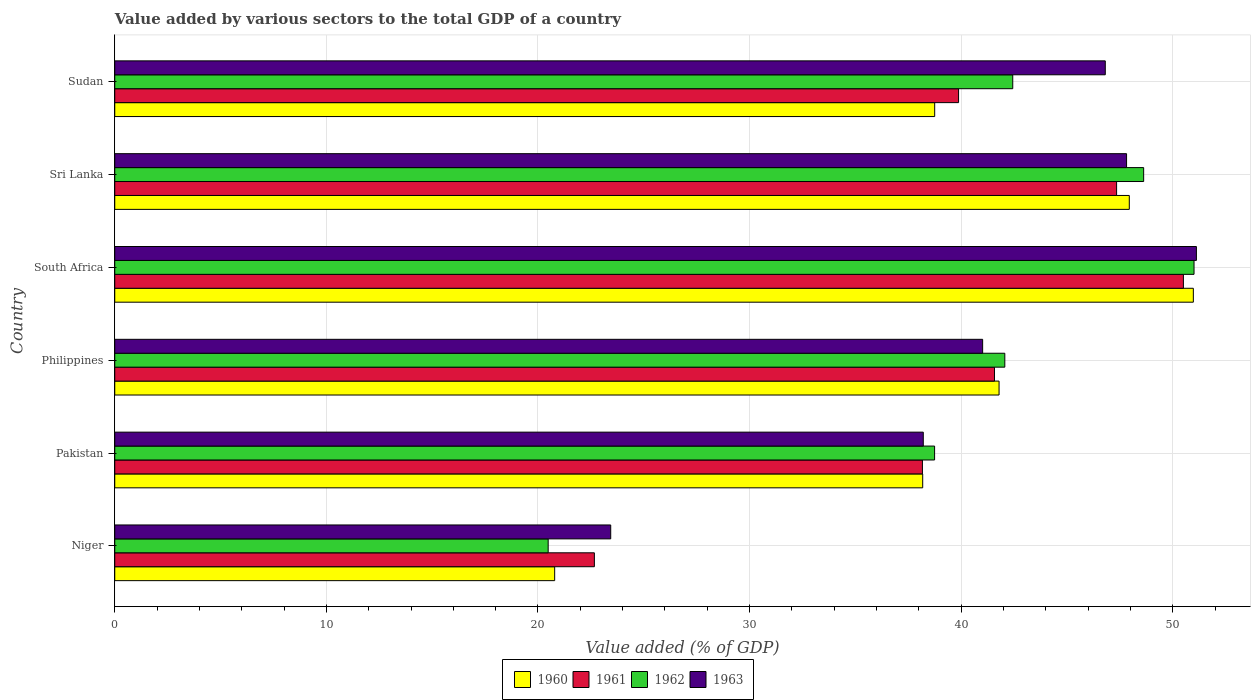How many groups of bars are there?
Make the answer very short. 6. Are the number of bars per tick equal to the number of legend labels?
Offer a very short reply. Yes. How many bars are there on the 3rd tick from the top?
Your response must be concise. 4. How many bars are there on the 1st tick from the bottom?
Provide a short and direct response. 4. What is the label of the 1st group of bars from the top?
Offer a very short reply. Sudan. What is the value added by various sectors to the total GDP in 1962 in Sri Lanka?
Provide a succinct answer. 48.62. Across all countries, what is the maximum value added by various sectors to the total GDP in 1960?
Give a very brief answer. 50.97. Across all countries, what is the minimum value added by various sectors to the total GDP in 1962?
Give a very brief answer. 20.48. In which country was the value added by various sectors to the total GDP in 1960 maximum?
Keep it short and to the point. South Africa. In which country was the value added by various sectors to the total GDP in 1963 minimum?
Ensure brevity in your answer.  Niger. What is the total value added by various sectors to the total GDP in 1962 in the graph?
Offer a terse response. 243.36. What is the difference between the value added by various sectors to the total GDP in 1960 in Philippines and that in Sri Lanka?
Offer a terse response. -6.15. What is the difference between the value added by various sectors to the total GDP in 1962 in South Africa and the value added by various sectors to the total GDP in 1963 in Pakistan?
Offer a very short reply. 12.8. What is the average value added by various sectors to the total GDP in 1960 per country?
Ensure brevity in your answer.  39.74. What is the difference between the value added by various sectors to the total GDP in 1960 and value added by various sectors to the total GDP in 1962 in Niger?
Offer a terse response. 0.31. What is the ratio of the value added by various sectors to the total GDP in 1962 in Niger to that in Philippines?
Make the answer very short. 0.49. Is the value added by various sectors to the total GDP in 1963 in Niger less than that in Philippines?
Give a very brief answer. Yes. Is the difference between the value added by various sectors to the total GDP in 1960 in South Africa and Sri Lanka greater than the difference between the value added by various sectors to the total GDP in 1962 in South Africa and Sri Lanka?
Offer a very short reply. Yes. What is the difference between the highest and the second highest value added by various sectors to the total GDP in 1961?
Your answer should be compact. 3.16. What is the difference between the highest and the lowest value added by various sectors to the total GDP in 1962?
Offer a terse response. 30.52. In how many countries, is the value added by various sectors to the total GDP in 1961 greater than the average value added by various sectors to the total GDP in 1961 taken over all countries?
Offer a very short reply. 3. How many bars are there?
Your response must be concise. 24. Are all the bars in the graph horizontal?
Your answer should be very brief. Yes. What is the difference between two consecutive major ticks on the X-axis?
Your answer should be very brief. 10. Are the values on the major ticks of X-axis written in scientific E-notation?
Offer a very short reply. No. How many legend labels are there?
Provide a succinct answer. 4. How are the legend labels stacked?
Provide a succinct answer. Horizontal. What is the title of the graph?
Your answer should be very brief. Value added by various sectors to the total GDP of a country. Does "1998" appear as one of the legend labels in the graph?
Keep it short and to the point. No. What is the label or title of the X-axis?
Keep it short and to the point. Value added (% of GDP). What is the label or title of the Y-axis?
Make the answer very short. Country. What is the Value added (% of GDP) in 1960 in Niger?
Ensure brevity in your answer.  20.79. What is the Value added (% of GDP) of 1961 in Niger?
Offer a terse response. 22.67. What is the Value added (% of GDP) of 1962 in Niger?
Provide a succinct answer. 20.48. What is the Value added (% of GDP) in 1963 in Niger?
Your answer should be compact. 23.44. What is the Value added (% of GDP) in 1960 in Pakistan?
Offer a very short reply. 38.18. What is the Value added (% of GDP) in 1961 in Pakistan?
Your answer should be compact. 38.17. What is the Value added (% of GDP) of 1962 in Pakistan?
Make the answer very short. 38.74. What is the Value added (% of GDP) of 1963 in Pakistan?
Your response must be concise. 38.21. What is the Value added (% of GDP) of 1960 in Philippines?
Keep it short and to the point. 41.79. What is the Value added (% of GDP) of 1961 in Philippines?
Ensure brevity in your answer.  41.57. What is the Value added (% of GDP) in 1962 in Philippines?
Provide a succinct answer. 42.06. What is the Value added (% of GDP) of 1963 in Philippines?
Give a very brief answer. 41.01. What is the Value added (% of GDP) in 1960 in South Africa?
Your answer should be very brief. 50.97. What is the Value added (% of GDP) of 1961 in South Africa?
Your response must be concise. 50.5. What is the Value added (% of GDP) in 1962 in South Africa?
Your answer should be very brief. 51.01. What is the Value added (% of GDP) of 1963 in South Africa?
Your answer should be compact. 51.12. What is the Value added (% of GDP) of 1960 in Sri Lanka?
Provide a short and direct response. 47.95. What is the Value added (% of GDP) in 1961 in Sri Lanka?
Make the answer very short. 47.35. What is the Value added (% of GDP) in 1962 in Sri Lanka?
Your response must be concise. 48.62. What is the Value added (% of GDP) of 1963 in Sri Lanka?
Your answer should be very brief. 47.82. What is the Value added (% of GDP) in 1960 in Sudan?
Provide a succinct answer. 38.75. What is the Value added (% of GDP) of 1961 in Sudan?
Provide a short and direct response. 39.88. What is the Value added (% of GDP) in 1962 in Sudan?
Your answer should be compact. 42.44. What is the Value added (% of GDP) in 1963 in Sudan?
Your answer should be very brief. 46.81. Across all countries, what is the maximum Value added (% of GDP) in 1960?
Keep it short and to the point. 50.97. Across all countries, what is the maximum Value added (% of GDP) of 1961?
Your answer should be compact. 50.5. Across all countries, what is the maximum Value added (% of GDP) of 1962?
Offer a very short reply. 51.01. Across all countries, what is the maximum Value added (% of GDP) in 1963?
Offer a terse response. 51.12. Across all countries, what is the minimum Value added (% of GDP) in 1960?
Keep it short and to the point. 20.79. Across all countries, what is the minimum Value added (% of GDP) in 1961?
Provide a short and direct response. 22.67. Across all countries, what is the minimum Value added (% of GDP) in 1962?
Your answer should be compact. 20.48. Across all countries, what is the minimum Value added (% of GDP) of 1963?
Offer a terse response. 23.44. What is the total Value added (% of GDP) of 1960 in the graph?
Give a very brief answer. 238.43. What is the total Value added (% of GDP) of 1961 in the graph?
Ensure brevity in your answer.  240.14. What is the total Value added (% of GDP) in 1962 in the graph?
Your response must be concise. 243.36. What is the total Value added (% of GDP) of 1963 in the graph?
Your response must be concise. 248.41. What is the difference between the Value added (% of GDP) of 1960 in Niger and that in Pakistan?
Provide a succinct answer. -17.39. What is the difference between the Value added (% of GDP) in 1961 in Niger and that in Pakistan?
Your answer should be compact. -15.5. What is the difference between the Value added (% of GDP) of 1962 in Niger and that in Pakistan?
Offer a terse response. -18.26. What is the difference between the Value added (% of GDP) of 1963 in Niger and that in Pakistan?
Give a very brief answer. -14.77. What is the difference between the Value added (% of GDP) in 1960 in Niger and that in Philippines?
Ensure brevity in your answer.  -21. What is the difference between the Value added (% of GDP) of 1961 in Niger and that in Philippines?
Give a very brief answer. -18.91. What is the difference between the Value added (% of GDP) in 1962 in Niger and that in Philippines?
Your answer should be compact. -21.58. What is the difference between the Value added (% of GDP) in 1963 in Niger and that in Philippines?
Give a very brief answer. -17.58. What is the difference between the Value added (% of GDP) of 1960 in Niger and that in South Africa?
Keep it short and to the point. -30.18. What is the difference between the Value added (% of GDP) of 1961 in Niger and that in South Africa?
Provide a succinct answer. -27.84. What is the difference between the Value added (% of GDP) in 1962 in Niger and that in South Africa?
Provide a short and direct response. -30.52. What is the difference between the Value added (% of GDP) of 1963 in Niger and that in South Africa?
Ensure brevity in your answer.  -27.68. What is the difference between the Value added (% of GDP) in 1960 in Niger and that in Sri Lanka?
Keep it short and to the point. -27.16. What is the difference between the Value added (% of GDP) in 1961 in Niger and that in Sri Lanka?
Your answer should be very brief. -24.68. What is the difference between the Value added (% of GDP) in 1962 in Niger and that in Sri Lanka?
Provide a short and direct response. -28.14. What is the difference between the Value added (% of GDP) in 1963 in Niger and that in Sri Lanka?
Your response must be concise. -24.38. What is the difference between the Value added (% of GDP) of 1960 in Niger and that in Sudan?
Your answer should be very brief. -17.96. What is the difference between the Value added (% of GDP) of 1961 in Niger and that in Sudan?
Ensure brevity in your answer.  -17.21. What is the difference between the Value added (% of GDP) of 1962 in Niger and that in Sudan?
Your answer should be compact. -21.96. What is the difference between the Value added (% of GDP) in 1963 in Niger and that in Sudan?
Your answer should be compact. -23.37. What is the difference between the Value added (% of GDP) of 1960 in Pakistan and that in Philippines?
Make the answer very short. -3.61. What is the difference between the Value added (% of GDP) of 1961 in Pakistan and that in Philippines?
Your answer should be compact. -3.41. What is the difference between the Value added (% of GDP) in 1962 in Pakistan and that in Philippines?
Your answer should be compact. -3.32. What is the difference between the Value added (% of GDP) of 1963 in Pakistan and that in Philippines?
Your answer should be compact. -2.81. What is the difference between the Value added (% of GDP) of 1960 in Pakistan and that in South Africa?
Your answer should be compact. -12.79. What is the difference between the Value added (% of GDP) in 1961 in Pakistan and that in South Africa?
Your response must be concise. -12.33. What is the difference between the Value added (% of GDP) of 1962 in Pakistan and that in South Africa?
Make the answer very short. -12.26. What is the difference between the Value added (% of GDP) of 1963 in Pakistan and that in South Africa?
Offer a very short reply. -12.91. What is the difference between the Value added (% of GDP) in 1960 in Pakistan and that in Sri Lanka?
Make the answer very short. -9.76. What is the difference between the Value added (% of GDP) in 1961 in Pakistan and that in Sri Lanka?
Give a very brief answer. -9.18. What is the difference between the Value added (% of GDP) of 1962 in Pakistan and that in Sri Lanka?
Your answer should be compact. -9.88. What is the difference between the Value added (% of GDP) of 1963 in Pakistan and that in Sri Lanka?
Your answer should be compact. -9.61. What is the difference between the Value added (% of GDP) of 1960 in Pakistan and that in Sudan?
Your answer should be very brief. -0.57. What is the difference between the Value added (% of GDP) of 1961 in Pakistan and that in Sudan?
Ensure brevity in your answer.  -1.71. What is the difference between the Value added (% of GDP) of 1962 in Pakistan and that in Sudan?
Keep it short and to the point. -3.69. What is the difference between the Value added (% of GDP) of 1963 in Pakistan and that in Sudan?
Ensure brevity in your answer.  -8.6. What is the difference between the Value added (% of GDP) in 1960 in Philippines and that in South Africa?
Your response must be concise. -9.18. What is the difference between the Value added (% of GDP) in 1961 in Philippines and that in South Africa?
Give a very brief answer. -8.93. What is the difference between the Value added (% of GDP) in 1962 in Philippines and that in South Africa?
Make the answer very short. -8.94. What is the difference between the Value added (% of GDP) of 1963 in Philippines and that in South Africa?
Offer a terse response. -10.1. What is the difference between the Value added (% of GDP) in 1960 in Philippines and that in Sri Lanka?
Keep it short and to the point. -6.15. What is the difference between the Value added (% of GDP) of 1961 in Philippines and that in Sri Lanka?
Provide a short and direct response. -5.77. What is the difference between the Value added (% of GDP) in 1962 in Philippines and that in Sri Lanka?
Your answer should be compact. -6.56. What is the difference between the Value added (% of GDP) in 1963 in Philippines and that in Sri Lanka?
Provide a short and direct response. -6.8. What is the difference between the Value added (% of GDP) in 1960 in Philippines and that in Sudan?
Give a very brief answer. 3.04. What is the difference between the Value added (% of GDP) of 1961 in Philippines and that in Sudan?
Your answer should be compact. 1.7. What is the difference between the Value added (% of GDP) in 1962 in Philippines and that in Sudan?
Provide a succinct answer. -0.38. What is the difference between the Value added (% of GDP) in 1963 in Philippines and that in Sudan?
Ensure brevity in your answer.  -5.8. What is the difference between the Value added (% of GDP) of 1960 in South Africa and that in Sri Lanka?
Offer a terse response. 3.03. What is the difference between the Value added (% of GDP) in 1961 in South Africa and that in Sri Lanka?
Make the answer very short. 3.16. What is the difference between the Value added (% of GDP) in 1962 in South Africa and that in Sri Lanka?
Offer a very short reply. 2.38. What is the difference between the Value added (% of GDP) in 1963 in South Africa and that in Sri Lanka?
Offer a very short reply. 3.3. What is the difference between the Value added (% of GDP) of 1960 in South Africa and that in Sudan?
Your answer should be compact. 12.22. What is the difference between the Value added (% of GDP) of 1961 in South Africa and that in Sudan?
Your answer should be very brief. 10.63. What is the difference between the Value added (% of GDP) of 1962 in South Africa and that in Sudan?
Your answer should be compact. 8.57. What is the difference between the Value added (% of GDP) in 1963 in South Africa and that in Sudan?
Your answer should be compact. 4.31. What is the difference between the Value added (% of GDP) in 1960 in Sri Lanka and that in Sudan?
Provide a short and direct response. 9.2. What is the difference between the Value added (% of GDP) of 1961 in Sri Lanka and that in Sudan?
Provide a short and direct response. 7.47. What is the difference between the Value added (% of GDP) of 1962 in Sri Lanka and that in Sudan?
Ensure brevity in your answer.  6.19. What is the difference between the Value added (% of GDP) of 1963 in Sri Lanka and that in Sudan?
Keep it short and to the point. 1.01. What is the difference between the Value added (% of GDP) of 1960 in Niger and the Value added (% of GDP) of 1961 in Pakistan?
Provide a short and direct response. -17.38. What is the difference between the Value added (% of GDP) of 1960 in Niger and the Value added (% of GDP) of 1962 in Pakistan?
Make the answer very short. -17.95. What is the difference between the Value added (% of GDP) in 1960 in Niger and the Value added (% of GDP) in 1963 in Pakistan?
Keep it short and to the point. -17.42. What is the difference between the Value added (% of GDP) in 1961 in Niger and the Value added (% of GDP) in 1962 in Pakistan?
Your response must be concise. -16.08. What is the difference between the Value added (% of GDP) in 1961 in Niger and the Value added (% of GDP) in 1963 in Pakistan?
Offer a terse response. -15.54. What is the difference between the Value added (% of GDP) of 1962 in Niger and the Value added (% of GDP) of 1963 in Pakistan?
Your response must be concise. -17.73. What is the difference between the Value added (% of GDP) of 1960 in Niger and the Value added (% of GDP) of 1961 in Philippines?
Provide a succinct answer. -20.78. What is the difference between the Value added (% of GDP) in 1960 in Niger and the Value added (% of GDP) in 1962 in Philippines?
Your answer should be very brief. -21.27. What is the difference between the Value added (% of GDP) of 1960 in Niger and the Value added (% of GDP) of 1963 in Philippines?
Keep it short and to the point. -20.22. What is the difference between the Value added (% of GDP) in 1961 in Niger and the Value added (% of GDP) in 1962 in Philippines?
Your answer should be very brief. -19.4. What is the difference between the Value added (% of GDP) of 1961 in Niger and the Value added (% of GDP) of 1963 in Philippines?
Your answer should be compact. -18.35. What is the difference between the Value added (% of GDP) in 1962 in Niger and the Value added (% of GDP) in 1963 in Philippines?
Give a very brief answer. -20.53. What is the difference between the Value added (% of GDP) of 1960 in Niger and the Value added (% of GDP) of 1961 in South Africa?
Make the answer very short. -29.71. What is the difference between the Value added (% of GDP) in 1960 in Niger and the Value added (% of GDP) in 1962 in South Africa?
Give a very brief answer. -30.22. What is the difference between the Value added (% of GDP) in 1960 in Niger and the Value added (% of GDP) in 1963 in South Africa?
Your answer should be compact. -30.33. What is the difference between the Value added (% of GDP) in 1961 in Niger and the Value added (% of GDP) in 1962 in South Africa?
Provide a short and direct response. -28.34. What is the difference between the Value added (% of GDP) in 1961 in Niger and the Value added (% of GDP) in 1963 in South Africa?
Ensure brevity in your answer.  -28.45. What is the difference between the Value added (% of GDP) of 1962 in Niger and the Value added (% of GDP) of 1963 in South Africa?
Your answer should be compact. -30.63. What is the difference between the Value added (% of GDP) of 1960 in Niger and the Value added (% of GDP) of 1961 in Sri Lanka?
Keep it short and to the point. -26.56. What is the difference between the Value added (% of GDP) in 1960 in Niger and the Value added (% of GDP) in 1962 in Sri Lanka?
Your answer should be very brief. -27.83. What is the difference between the Value added (% of GDP) in 1960 in Niger and the Value added (% of GDP) in 1963 in Sri Lanka?
Give a very brief answer. -27.03. What is the difference between the Value added (% of GDP) of 1961 in Niger and the Value added (% of GDP) of 1962 in Sri Lanka?
Your answer should be compact. -25.96. What is the difference between the Value added (% of GDP) of 1961 in Niger and the Value added (% of GDP) of 1963 in Sri Lanka?
Your answer should be very brief. -25.15. What is the difference between the Value added (% of GDP) of 1962 in Niger and the Value added (% of GDP) of 1963 in Sri Lanka?
Keep it short and to the point. -27.33. What is the difference between the Value added (% of GDP) of 1960 in Niger and the Value added (% of GDP) of 1961 in Sudan?
Your answer should be very brief. -19.09. What is the difference between the Value added (% of GDP) in 1960 in Niger and the Value added (% of GDP) in 1962 in Sudan?
Keep it short and to the point. -21.65. What is the difference between the Value added (% of GDP) of 1960 in Niger and the Value added (% of GDP) of 1963 in Sudan?
Offer a very short reply. -26.02. What is the difference between the Value added (% of GDP) of 1961 in Niger and the Value added (% of GDP) of 1962 in Sudan?
Give a very brief answer. -19.77. What is the difference between the Value added (% of GDP) in 1961 in Niger and the Value added (% of GDP) in 1963 in Sudan?
Your answer should be compact. -24.14. What is the difference between the Value added (% of GDP) in 1962 in Niger and the Value added (% of GDP) in 1963 in Sudan?
Offer a terse response. -26.33. What is the difference between the Value added (% of GDP) in 1960 in Pakistan and the Value added (% of GDP) in 1961 in Philippines?
Offer a terse response. -3.39. What is the difference between the Value added (% of GDP) of 1960 in Pakistan and the Value added (% of GDP) of 1962 in Philippines?
Keep it short and to the point. -3.88. What is the difference between the Value added (% of GDP) in 1960 in Pakistan and the Value added (% of GDP) in 1963 in Philippines?
Keep it short and to the point. -2.83. What is the difference between the Value added (% of GDP) in 1961 in Pakistan and the Value added (% of GDP) in 1962 in Philippines?
Your response must be concise. -3.89. What is the difference between the Value added (% of GDP) in 1961 in Pakistan and the Value added (% of GDP) in 1963 in Philippines?
Your answer should be compact. -2.85. What is the difference between the Value added (% of GDP) of 1962 in Pakistan and the Value added (% of GDP) of 1963 in Philippines?
Give a very brief answer. -2.27. What is the difference between the Value added (% of GDP) of 1960 in Pakistan and the Value added (% of GDP) of 1961 in South Africa?
Provide a short and direct response. -12.32. What is the difference between the Value added (% of GDP) of 1960 in Pakistan and the Value added (% of GDP) of 1962 in South Africa?
Provide a succinct answer. -12.82. What is the difference between the Value added (% of GDP) of 1960 in Pakistan and the Value added (% of GDP) of 1963 in South Africa?
Make the answer very short. -12.93. What is the difference between the Value added (% of GDP) in 1961 in Pakistan and the Value added (% of GDP) in 1962 in South Africa?
Make the answer very short. -12.84. What is the difference between the Value added (% of GDP) in 1961 in Pakistan and the Value added (% of GDP) in 1963 in South Africa?
Your response must be concise. -12.95. What is the difference between the Value added (% of GDP) in 1962 in Pakistan and the Value added (% of GDP) in 1963 in South Africa?
Offer a very short reply. -12.37. What is the difference between the Value added (% of GDP) in 1960 in Pakistan and the Value added (% of GDP) in 1961 in Sri Lanka?
Your response must be concise. -9.16. What is the difference between the Value added (% of GDP) in 1960 in Pakistan and the Value added (% of GDP) in 1962 in Sri Lanka?
Offer a terse response. -10.44. What is the difference between the Value added (% of GDP) in 1960 in Pakistan and the Value added (% of GDP) in 1963 in Sri Lanka?
Your answer should be compact. -9.63. What is the difference between the Value added (% of GDP) of 1961 in Pakistan and the Value added (% of GDP) of 1962 in Sri Lanka?
Give a very brief answer. -10.46. What is the difference between the Value added (% of GDP) of 1961 in Pakistan and the Value added (% of GDP) of 1963 in Sri Lanka?
Offer a terse response. -9.65. What is the difference between the Value added (% of GDP) in 1962 in Pakistan and the Value added (% of GDP) in 1963 in Sri Lanka?
Ensure brevity in your answer.  -9.07. What is the difference between the Value added (% of GDP) in 1960 in Pakistan and the Value added (% of GDP) in 1961 in Sudan?
Your answer should be compact. -1.69. What is the difference between the Value added (% of GDP) in 1960 in Pakistan and the Value added (% of GDP) in 1962 in Sudan?
Ensure brevity in your answer.  -4.26. What is the difference between the Value added (% of GDP) of 1960 in Pakistan and the Value added (% of GDP) of 1963 in Sudan?
Make the answer very short. -8.63. What is the difference between the Value added (% of GDP) of 1961 in Pakistan and the Value added (% of GDP) of 1962 in Sudan?
Provide a short and direct response. -4.27. What is the difference between the Value added (% of GDP) of 1961 in Pakistan and the Value added (% of GDP) of 1963 in Sudan?
Offer a terse response. -8.64. What is the difference between the Value added (% of GDP) in 1962 in Pakistan and the Value added (% of GDP) in 1963 in Sudan?
Give a very brief answer. -8.07. What is the difference between the Value added (% of GDP) of 1960 in Philippines and the Value added (% of GDP) of 1961 in South Africa?
Keep it short and to the point. -8.71. What is the difference between the Value added (% of GDP) in 1960 in Philippines and the Value added (% of GDP) in 1962 in South Africa?
Provide a short and direct response. -9.21. What is the difference between the Value added (% of GDP) in 1960 in Philippines and the Value added (% of GDP) in 1963 in South Africa?
Make the answer very short. -9.33. What is the difference between the Value added (% of GDP) in 1961 in Philippines and the Value added (% of GDP) in 1962 in South Africa?
Offer a very short reply. -9.43. What is the difference between the Value added (% of GDP) in 1961 in Philippines and the Value added (% of GDP) in 1963 in South Africa?
Keep it short and to the point. -9.54. What is the difference between the Value added (% of GDP) of 1962 in Philippines and the Value added (% of GDP) of 1963 in South Africa?
Keep it short and to the point. -9.05. What is the difference between the Value added (% of GDP) of 1960 in Philippines and the Value added (% of GDP) of 1961 in Sri Lanka?
Make the answer very short. -5.55. What is the difference between the Value added (% of GDP) in 1960 in Philippines and the Value added (% of GDP) in 1962 in Sri Lanka?
Ensure brevity in your answer.  -6.83. What is the difference between the Value added (% of GDP) in 1960 in Philippines and the Value added (% of GDP) in 1963 in Sri Lanka?
Offer a very short reply. -6.03. What is the difference between the Value added (% of GDP) of 1961 in Philippines and the Value added (% of GDP) of 1962 in Sri Lanka?
Your answer should be compact. -7.05. What is the difference between the Value added (% of GDP) in 1961 in Philippines and the Value added (% of GDP) in 1963 in Sri Lanka?
Offer a very short reply. -6.24. What is the difference between the Value added (% of GDP) of 1962 in Philippines and the Value added (% of GDP) of 1963 in Sri Lanka?
Offer a very short reply. -5.75. What is the difference between the Value added (% of GDP) of 1960 in Philippines and the Value added (% of GDP) of 1961 in Sudan?
Ensure brevity in your answer.  1.91. What is the difference between the Value added (% of GDP) of 1960 in Philippines and the Value added (% of GDP) of 1962 in Sudan?
Make the answer very short. -0.65. What is the difference between the Value added (% of GDP) in 1960 in Philippines and the Value added (% of GDP) in 1963 in Sudan?
Keep it short and to the point. -5.02. What is the difference between the Value added (% of GDP) of 1961 in Philippines and the Value added (% of GDP) of 1962 in Sudan?
Provide a succinct answer. -0.86. What is the difference between the Value added (% of GDP) in 1961 in Philippines and the Value added (% of GDP) in 1963 in Sudan?
Make the answer very short. -5.24. What is the difference between the Value added (% of GDP) of 1962 in Philippines and the Value added (% of GDP) of 1963 in Sudan?
Ensure brevity in your answer.  -4.75. What is the difference between the Value added (% of GDP) in 1960 in South Africa and the Value added (% of GDP) in 1961 in Sri Lanka?
Offer a very short reply. 3.63. What is the difference between the Value added (% of GDP) of 1960 in South Africa and the Value added (% of GDP) of 1962 in Sri Lanka?
Offer a terse response. 2.35. What is the difference between the Value added (% of GDP) of 1960 in South Africa and the Value added (% of GDP) of 1963 in Sri Lanka?
Your answer should be compact. 3.16. What is the difference between the Value added (% of GDP) in 1961 in South Africa and the Value added (% of GDP) in 1962 in Sri Lanka?
Offer a terse response. 1.88. What is the difference between the Value added (% of GDP) of 1961 in South Africa and the Value added (% of GDP) of 1963 in Sri Lanka?
Offer a terse response. 2.69. What is the difference between the Value added (% of GDP) in 1962 in South Africa and the Value added (% of GDP) in 1963 in Sri Lanka?
Give a very brief answer. 3.19. What is the difference between the Value added (% of GDP) in 1960 in South Africa and the Value added (% of GDP) in 1961 in Sudan?
Make the answer very short. 11.09. What is the difference between the Value added (% of GDP) in 1960 in South Africa and the Value added (% of GDP) in 1962 in Sudan?
Your answer should be compact. 8.53. What is the difference between the Value added (% of GDP) in 1960 in South Africa and the Value added (% of GDP) in 1963 in Sudan?
Give a very brief answer. 4.16. What is the difference between the Value added (% of GDP) in 1961 in South Africa and the Value added (% of GDP) in 1962 in Sudan?
Keep it short and to the point. 8.07. What is the difference between the Value added (% of GDP) of 1961 in South Africa and the Value added (% of GDP) of 1963 in Sudan?
Your answer should be very brief. 3.69. What is the difference between the Value added (% of GDP) of 1962 in South Africa and the Value added (% of GDP) of 1963 in Sudan?
Keep it short and to the point. 4.19. What is the difference between the Value added (% of GDP) in 1960 in Sri Lanka and the Value added (% of GDP) in 1961 in Sudan?
Make the answer very short. 8.07. What is the difference between the Value added (% of GDP) of 1960 in Sri Lanka and the Value added (% of GDP) of 1962 in Sudan?
Make the answer very short. 5.51. What is the difference between the Value added (% of GDP) of 1960 in Sri Lanka and the Value added (% of GDP) of 1963 in Sudan?
Your answer should be compact. 1.14. What is the difference between the Value added (% of GDP) of 1961 in Sri Lanka and the Value added (% of GDP) of 1962 in Sudan?
Make the answer very short. 4.91. What is the difference between the Value added (% of GDP) of 1961 in Sri Lanka and the Value added (% of GDP) of 1963 in Sudan?
Provide a succinct answer. 0.53. What is the difference between the Value added (% of GDP) in 1962 in Sri Lanka and the Value added (% of GDP) in 1963 in Sudan?
Provide a succinct answer. 1.81. What is the average Value added (% of GDP) of 1960 per country?
Give a very brief answer. 39.74. What is the average Value added (% of GDP) in 1961 per country?
Make the answer very short. 40.02. What is the average Value added (% of GDP) of 1962 per country?
Offer a very short reply. 40.56. What is the average Value added (% of GDP) of 1963 per country?
Keep it short and to the point. 41.4. What is the difference between the Value added (% of GDP) in 1960 and Value added (% of GDP) in 1961 in Niger?
Your answer should be very brief. -1.88. What is the difference between the Value added (% of GDP) in 1960 and Value added (% of GDP) in 1962 in Niger?
Provide a short and direct response. 0.31. What is the difference between the Value added (% of GDP) in 1960 and Value added (% of GDP) in 1963 in Niger?
Offer a very short reply. -2.65. What is the difference between the Value added (% of GDP) in 1961 and Value added (% of GDP) in 1962 in Niger?
Make the answer very short. 2.18. What is the difference between the Value added (% of GDP) of 1961 and Value added (% of GDP) of 1963 in Niger?
Offer a very short reply. -0.77. What is the difference between the Value added (% of GDP) in 1962 and Value added (% of GDP) in 1963 in Niger?
Give a very brief answer. -2.96. What is the difference between the Value added (% of GDP) in 1960 and Value added (% of GDP) in 1961 in Pakistan?
Keep it short and to the point. 0.01. What is the difference between the Value added (% of GDP) of 1960 and Value added (% of GDP) of 1962 in Pakistan?
Make the answer very short. -0.56. What is the difference between the Value added (% of GDP) in 1960 and Value added (% of GDP) in 1963 in Pakistan?
Your answer should be very brief. -0.03. What is the difference between the Value added (% of GDP) of 1961 and Value added (% of GDP) of 1962 in Pakistan?
Your answer should be compact. -0.58. What is the difference between the Value added (% of GDP) of 1961 and Value added (% of GDP) of 1963 in Pakistan?
Make the answer very short. -0.04. What is the difference between the Value added (% of GDP) in 1962 and Value added (% of GDP) in 1963 in Pakistan?
Your answer should be compact. 0.53. What is the difference between the Value added (% of GDP) in 1960 and Value added (% of GDP) in 1961 in Philippines?
Your answer should be compact. 0.22. What is the difference between the Value added (% of GDP) of 1960 and Value added (% of GDP) of 1962 in Philippines?
Your answer should be compact. -0.27. What is the difference between the Value added (% of GDP) in 1960 and Value added (% of GDP) in 1963 in Philippines?
Provide a succinct answer. 0.78. What is the difference between the Value added (% of GDP) of 1961 and Value added (% of GDP) of 1962 in Philippines?
Offer a very short reply. -0.49. What is the difference between the Value added (% of GDP) in 1961 and Value added (% of GDP) in 1963 in Philippines?
Give a very brief answer. 0.56. What is the difference between the Value added (% of GDP) of 1962 and Value added (% of GDP) of 1963 in Philippines?
Keep it short and to the point. 1.05. What is the difference between the Value added (% of GDP) of 1960 and Value added (% of GDP) of 1961 in South Africa?
Provide a short and direct response. 0.47. What is the difference between the Value added (% of GDP) of 1960 and Value added (% of GDP) of 1962 in South Africa?
Provide a succinct answer. -0.03. What is the difference between the Value added (% of GDP) in 1960 and Value added (% of GDP) in 1963 in South Africa?
Your answer should be very brief. -0.15. What is the difference between the Value added (% of GDP) of 1961 and Value added (% of GDP) of 1962 in South Africa?
Offer a terse response. -0.5. What is the difference between the Value added (% of GDP) of 1961 and Value added (% of GDP) of 1963 in South Africa?
Your answer should be compact. -0.61. What is the difference between the Value added (% of GDP) of 1962 and Value added (% of GDP) of 1963 in South Africa?
Provide a succinct answer. -0.11. What is the difference between the Value added (% of GDP) in 1960 and Value added (% of GDP) in 1961 in Sri Lanka?
Ensure brevity in your answer.  0.6. What is the difference between the Value added (% of GDP) of 1960 and Value added (% of GDP) of 1962 in Sri Lanka?
Give a very brief answer. -0.68. What is the difference between the Value added (% of GDP) in 1960 and Value added (% of GDP) in 1963 in Sri Lanka?
Give a very brief answer. 0.13. What is the difference between the Value added (% of GDP) in 1961 and Value added (% of GDP) in 1962 in Sri Lanka?
Your response must be concise. -1.28. What is the difference between the Value added (% of GDP) of 1961 and Value added (% of GDP) of 1963 in Sri Lanka?
Your response must be concise. -0.47. What is the difference between the Value added (% of GDP) of 1962 and Value added (% of GDP) of 1963 in Sri Lanka?
Keep it short and to the point. 0.81. What is the difference between the Value added (% of GDP) in 1960 and Value added (% of GDP) in 1961 in Sudan?
Offer a very short reply. -1.13. What is the difference between the Value added (% of GDP) of 1960 and Value added (% of GDP) of 1962 in Sudan?
Your answer should be compact. -3.69. What is the difference between the Value added (% of GDP) in 1960 and Value added (% of GDP) in 1963 in Sudan?
Your response must be concise. -8.06. What is the difference between the Value added (% of GDP) of 1961 and Value added (% of GDP) of 1962 in Sudan?
Ensure brevity in your answer.  -2.56. What is the difference between the Value added (% of GDP) of 1961 and Value added (% of GDP) of 1963 in Sudan?
Make the answer very short. -6.93. What is the difference between the Value added (% of GDP) of 1962 and Value added (% of GDP) of 1963 in Sudan?
Give a very brief answer. -4.37. What is the ratio of the Value added (% of GDP) in 1960 in Niger to that in Pakistan?
Provide a short and direct response. 0.54. What is the ratio of the Value added (% of GDP) in 1961 in Niger to that in Pakistan?
Make the answer very short. 0.59. What is the ratio of the Value added (% of GDP) of 1962 in Niger to that in Pakistan?
Provide a short and direct response. 0.53. What is the ratio of the Value added (% of GDP) in 1963 in Niger to that in Pakistan?
Make the answer very short. 0.61. What is the ratio of the Value added (% of GDP) of 1960 in Niger to that in Philippines?
Provide a succinct answer. 0.5. What is the ratio of the Value added (% of GDP) of 1961 in Niger to that in Philippines?
Make the answer very short. 0.55. What is the ratio of the Value added (% of GDP) in 1962 in Niger to that in Philippines?
Keep it short and to the point. 0.49. What is the ratio of the Value added (% of GDP) of 1963 in Niger to that in Philippines?
Your answer should be very brief. 0.57. What is the ratio of the Value added (% of GDP) of 1960 in Niger to that in South Africa?
Your answer should be very brief. 0.41. What is the ratio of the Value added (% of GDP) in 1961 in Niger to that in South Africa?
Your response must be concise. 0.45. What is the ratio of the Value added (% of GDP) in 1962 in Niger to that in South Africa?
Offer a terse response. 0.4. What is the ratio of the Value added (% of GDP) in 1963 in Niger to that in South Africa?
Your answer should be compact. 0.46. What is the ratio of the Value added (% of GDP) of 1960 in Niger to that in Sri Lanka?
Your response must be concise. 0.43. What is the ratio of the Value added (% of GDP) of 1961 in Niger to that in Sri Lanka?
Provide a succinct answer. 0.48. What is the ratio of the Value added (% of GDP) of 1962 in Niger to that in Sri Lanka?
Ensure brevity in your answer.  0.42. What is the ratio of the Value added (% of GDP) of 1963 in Niger to that in Sri Lanka?
Your response must be concise. 0.49. What is the ratio of the Value added (% of GDP) in 1960 in Niger to that in Sudan?
Your answer should be compact. 0.54. What is the ratio of the Value added (% of GDP) in 1961 in Niger to that in Sudan?
Ensure brevity in your answer.  0.57. What is the ratio of the Value added (% of GDP) in 1962 in Niger to that in Sudan?
Give a very brief answer. 0.48. What is the ratio of the Value added (% of GDP) in 1963 in Niger to that in Sudan?
Your response must be concise. 0.5. What is the ratio of the Value added (% of GDP) of 1960 in Pakistan to that in Philippines?
Offer a terse response. 0.91. What is the ratio of the Value added (% of GDP) of 1961 in Pakistan to that in Philippines?
Provide a succinct answer. 0.92. What is the ratio of the Value added (% of GDP) of 1962 in Pakistan to that in Philippines?
Give a very brief answer. 0.92. What is the ratio of the Value added (% of GDP) in 1963 in Pakistan to that in Philippines?
Ensure brevity in your answer.  0.93. What is the ratio of the Value added (% of GDP) of 1960 in Pakistan to that in South Africa?
Offer a terse response. 0.75. What is the ratio of the Value added (% of GDP) in 1961 in Pakistan to that in South Africa?
Your response must be concise. 0.76. What is the ratio of the Value added (% of GDP) of 1962 in Pakistan to that in South Africa?
Provide a short and direct response. 0.76. What is the ratio of the Value added (% of GDP) of 1963 in Pakistan to that in South Africa?
Offer a terse response. 0.75. What is the ratio of the Value added (% of GDP) in 1960 in Pakistan to that in Sri Lanka?
Ensure brevity in your answer.  0.8. What is the ratio of the Value added (% of GDP) in 1961 in Pakistan to that in Sri Lanka?
Your answer should be compact. 0.81. What is the ratio of the Value added (% of GDP) in 1962 in Pakistan to that in Sri Lanka?
Ensure brevity in your answer.  0.8. What is the ratio of the Value added (% of GDP) in 1963 in Pakistan to that in Sri Lanka?
Provide a short and direct response. 0.8. What is the ratio of the Value added (% of GDP) of 1960 in Pakistan to that in Sudan?
Make the answer very short. 0.99. What is the ratio of the Value added (% of GDP) in 1961 in Pakistan to that in Sudan?
Keep it short and to the point. 0.96. What is the ratio of the Value added (% of GDP) in 1962 in Pakistan to that in Sudan?
Make the answer very short. 0.91. What is the ratio of the Value added (% of GDP) in 1963 in Pakistan to that in Sudan?
Your answer should be very brief. 0.82. What is the ratio of the Value added (% of GDP) of 1960 in Philippines to that in South Africa?
Ensure brevity in your answer.  0.82. What is the ratio of the Value added (% of GDP) in 1961 in Philippines to that in South Africa?
Keep it short and to the point. 0.82. What is the ratio of the Value added (% of GDP) in 1962 in Philippines to that in South Africa?
Provide a short and direct response. 0.82. What is the ratio of the Value added (% of GDP) of 1963 in Philippines to that in South Africa?
Give a very brief answer. 0.8. What is the ratio of the Value added (% of GDP) in 1960 in Philippines to that in Sri Lanka?
Your answer should be compact. 0.87. What is the ratio of the Value added (% of GDP) in 1961 in Philippines to that in Sri Lanka?
Offer a very short reply. 0.88. What is the ratio of the Value added (% of GDP) in 1962 in Philippines to that in Sri Lanka?
Your answer should be compact. 0.87. What is the ratio of the Value added (% of GDP) in 1963 in Philippines to that in Sri Lanka?
Offer a terse response. 0.86. What is the ratio of the Value added (% of GDP) in 1960 in Philippines to that in Sudan?
Make the answer very short. 1.08. What is the ratio of the Value added (% of GDP) of 1961 in Philippines to that in Sudan?
Offer a very short reply. 1.04. What is the ratio of the Value added (% of GDP) in 1962 in Philippines to that in Sudan?
Your answer should be very brief. 0.99. What is the ratio of the Value added (% of GDP) of 1963 in Philippines to that in Sudan?
Offer a terse response. 0.88. What is the ratio of the Value added (% of GDP) in 1960 in South Africa to that in Sri Lanka?
Your response must be concise. 1.06. What is the ratio of the Value added (% of GDP) of 1961 in South Africa to that in Sri Lanka?
Provide a succinct answer. 1.07. What is the ratio of the Value added (% of GDP) of 1962 in South Africa to that in Sri Lanka?
Offer a terse response. 1.05. What is the ratio of the Value added (% of GDP) of 1963 in South Africa to that in Sri Lanka?
Offer a terse response. 1.07. What is the ratio of the Value added (% of GDP) of 1960 in South Africa to that in Sudan?
Provide a succinct answer. 1.32. What is the ratio of the Value added (% of GDP) of 1961 in South Africa to that in Sudan?
Your answer should be very brief. 1.27. What is the ratio of the Value added (% of GDP) in 1962 in South Africa to that in Sudan?
Provide a short and direct response. 1.2. What is the ratio of the Value added (% of GDP) of 1963 in South Africa to that in Sudan?
Your answer should be compact. 1.09. What is the ratio of the Value added (% of GDP) in 1960 in Sri Lanka to that in Sudan?
Provide a succinct answer. 1.24. What is the ratio of the Value added (% of GDP) of 1961 in Sri Lanka to that in Sudan?
Ensure brevity in your answer.  1.19. What is the ratio of the Value added (% of GDP) of 1962 in Sri Lanka to that in Sudan?
Offer a terse response. 1.15. What is the ratio of the Value added (% of GDP) of 1963 in Sri Lanka to that in Sudan?
Your response must be concise. 1.02. What is the difference between the highest and the second highest Value added (% of GDP) of 1960?
Ensure brevity in your answer.  3.03. What is the difference between the highest and the second highest Value added (% of GDP) in 1961?
Your response must be concise. 3.16. What is the difference between the highest and the second highest Value added (% of GDP) of 1962?
Your answer should be very brief. 2.38. What is the difference between the highest and the second highest Value added (% of GDP) of 1963?
Your answer should be compact. 3.3. What is the difference between the highest and the lowest Value added (% of GDP) in 1960?
Your response must be concise. 30.18. What is the difference between the highest and the lowest Value added (% of GDP) in 1961?
Keep it short and to the point. 27.84. What is the difference between the highest and the lowest Value added (% of GDP) in 1962?
Provide a short and direct response. 30.52. What is the difference between the highest and the lowest Value added (% of GDP) of 1963?
Keep it short and to the point. 27.68. 